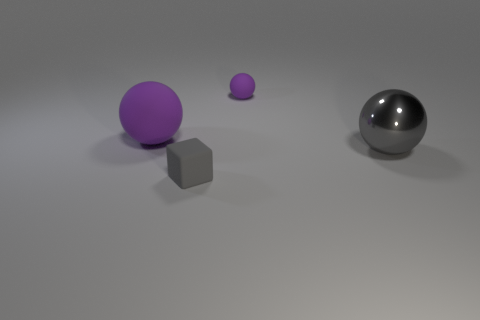Add 4 large spheres. How many objects exist? 8 Subtract all large gray spheres. How many spheres are left? 2 Subtract all gray balls. How many balls are left? 2 Add 1 big purple balls. How many big purple balls exist? 2 Subtract 0 blue balls. How many objects are left? 4 Subtract all cubes. How many objects are left? 3 Subtract 1 cubes. How many cubes are left? 0 Subtract all blue balls. Subtract all red blocks. How many balls are left? 3 Subtract all blue balls. How many blue blocks are left? 0 Subtract all small green blocks. Subtract all purple objects. How many objects are left? 2 